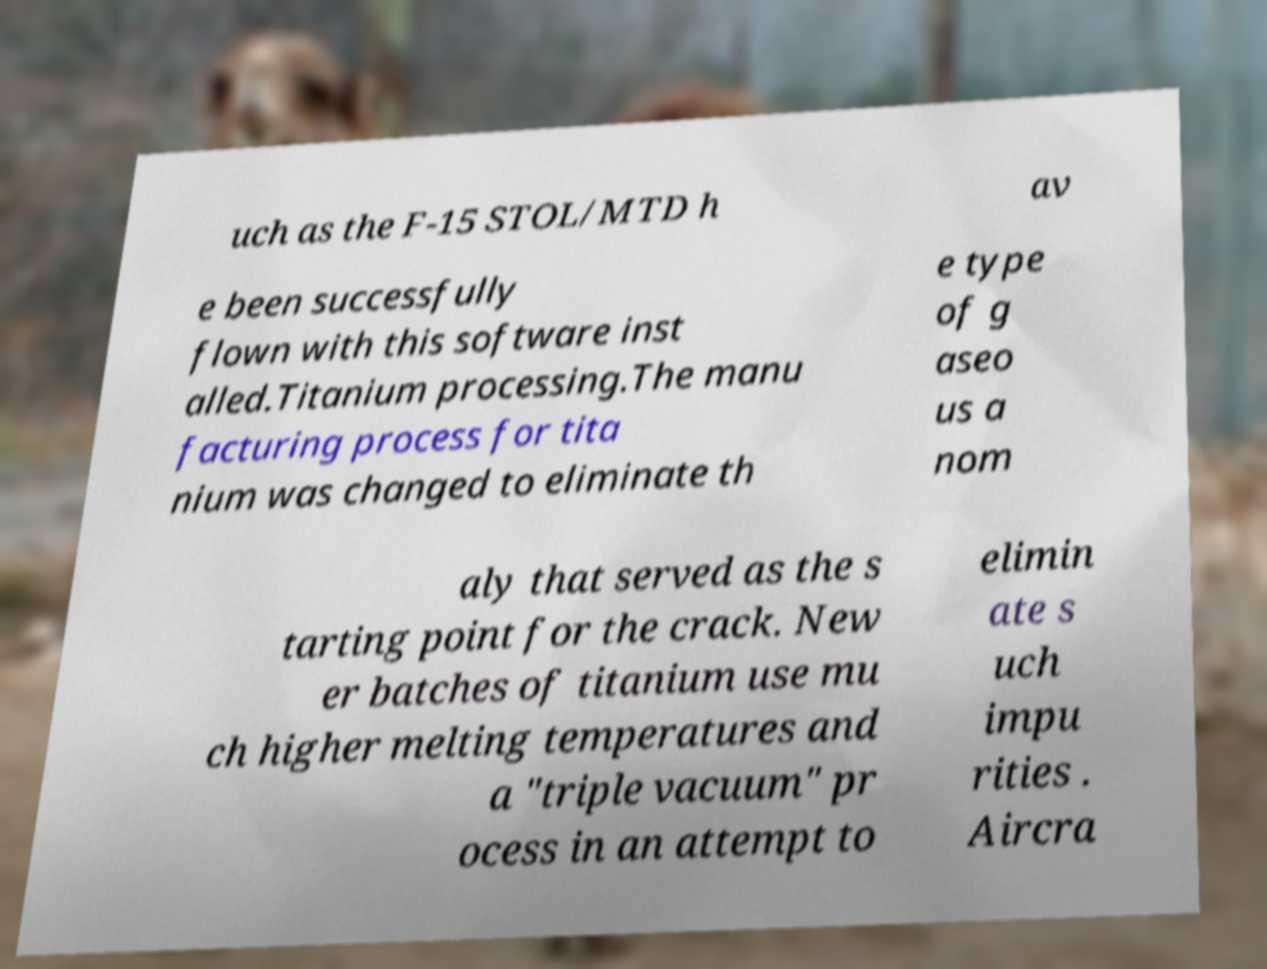Please read and relay the text visible in this image. What does it say? uch as the F-15 STOL/MTD h av e been successfully flown with this software inst alled.Titanium processing.The manu facturing process for tita nium was changed to eliminate th e type of g aseo us a nom aly that served as the s tarting point for the crack. New er batches of titanium use mu ch higher melting temperatures and a "triple vacuum" pr ocess in an attempt to elimin ate s uch impu rities . Aircra 